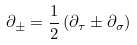<formula> <loc_0><loc_0><loc_500><loc_500>\partial _ { \pm } = \frac { 1 } { 2 } \left ( \partial _ { \tau } \pm \partial _ { \sigma } \right )</formula> 